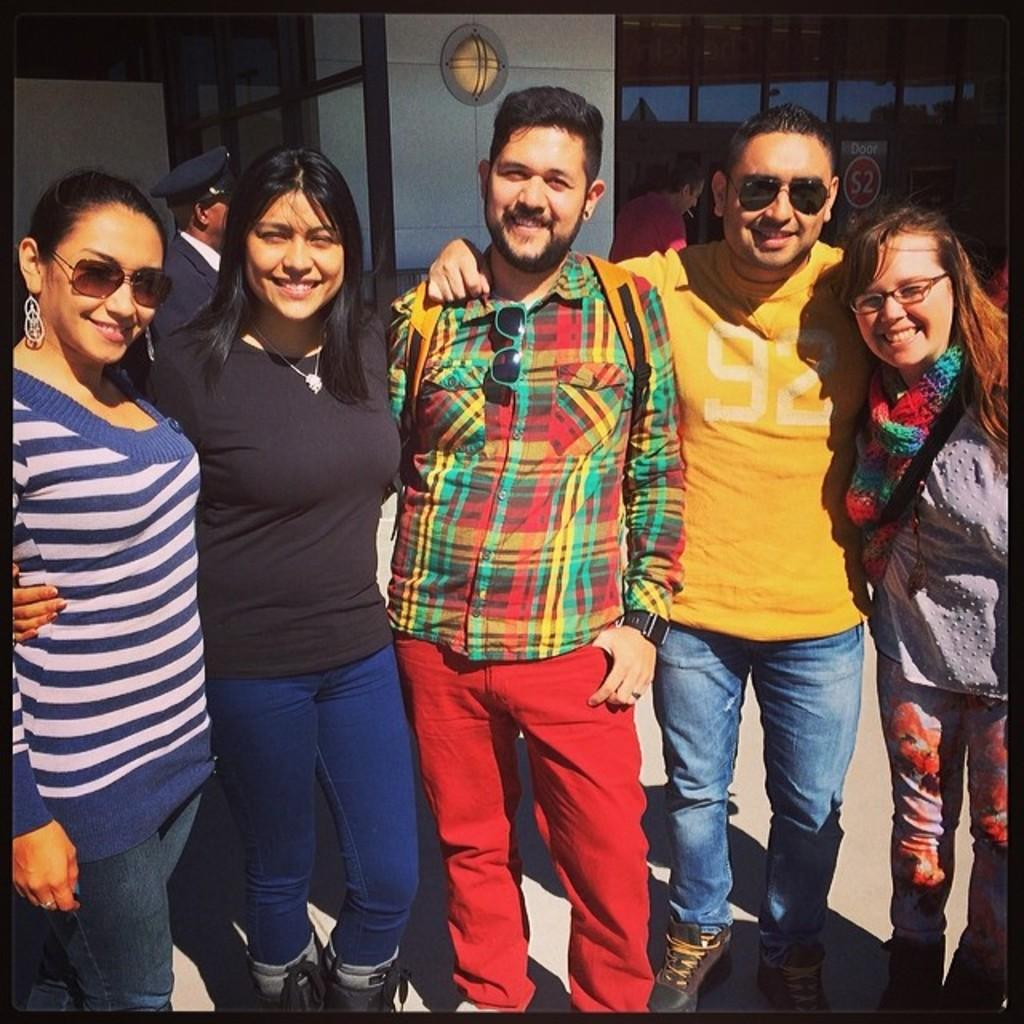What is happening with the group of people in the image? The people are standing together in the image. What is the mood or expression of the people in the image? The people are smiling in the image. What can be seen in the background of the image? There is a building with a glass wall in the background, and there is a person visible in the background. How many people are jumping in the image? There are no people jumping in the image. 